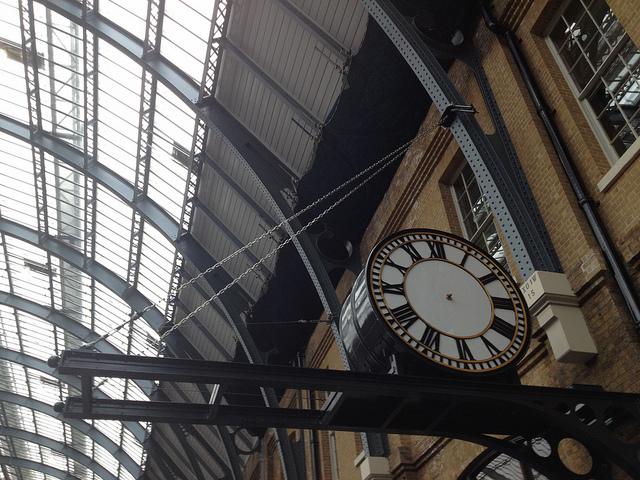Are the parts of this clock messing?
Write a very short answer. Yes. How many panes do each of the windows have?
Answer briefly. 18. What kind do numbers are on the clock face?
Keep it brief. Roman numerals. How many clocks are there?
Be succinct. 1. 